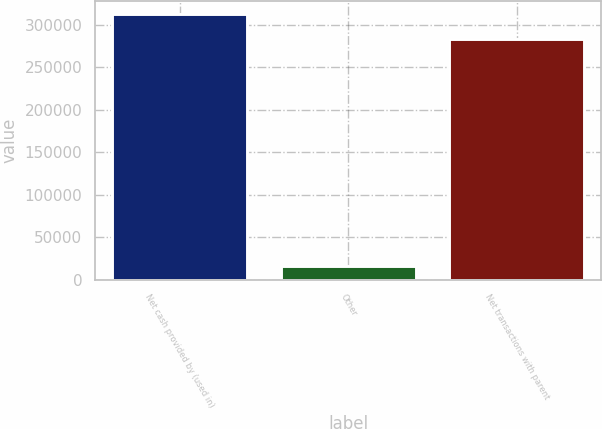Convert chart to OTSL. <chart><loc_0><loc_0><loc_500><loc_500><bar_chart><fcel>Net cash provided by (used in)<fcel>Other<fcel>Net transactions with parent<nl><fcel>312405<fcel>16760<fcel>283890<nl></chart> 